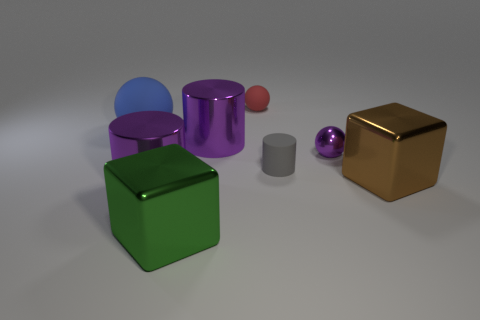Add 1 small red rubber spheres. How many objects exist? 9 Subtract all purple spheres. How many spheres are left? 2 Subtract 1 blocks. How many blocks are left? 1 Subtract all balls. How many objects are left? 5 Subtract all red balls. How many balls are left? 2 Subtract all green blocks. Subtract all cyan spheres. How many blocks are left? 1 Subtract 1 brown blocks. How many objects are left? 7 Subtract all gray cylinders. How many red spheres are left? 1 Subtract all large yellow matte cylinders. Subtract all big matte objects. How many objects are left? 7 Add 7 gray objects. How many gray objects are left? 8 